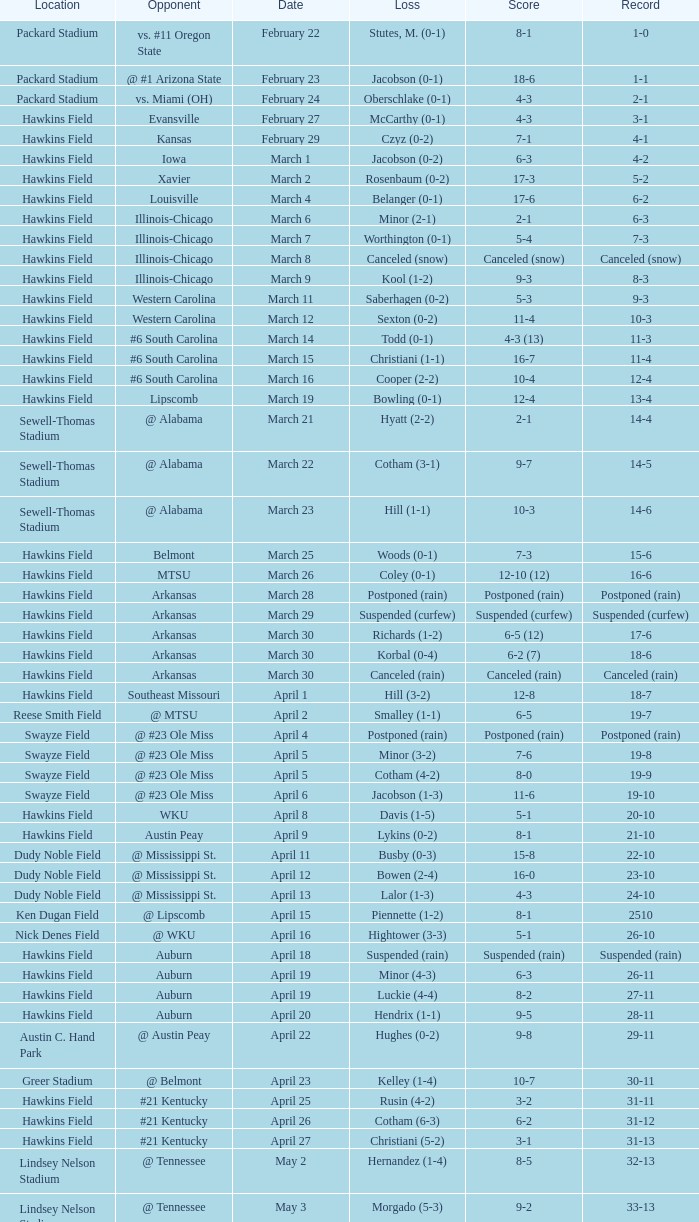What was the location of the game when the record was 2-1? Packard Stadium. 